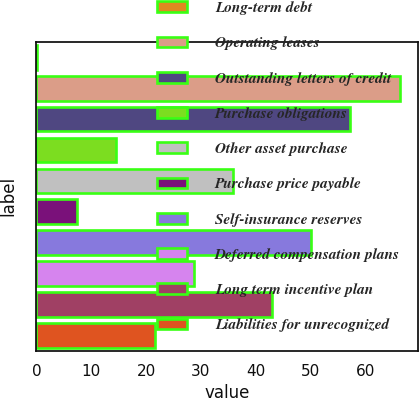Convert chart. <chart><loc_0><loc_0><loc_500><loc_500><bar_chart><fcel>Long-term debt<fcel>Operating leases<fcel>Outstanding letters of credit<fcel>Purchase obligations<fcel>Other asset purchase<fcel>Purchase price payable<fcel>Self-insurance reserves<fcel>Deferred compensation plans<fcel>Long term incentive plan<fcel>Liabilities for unrecognized<nl><fcel>0.2<fcel>66.3<fcel>57.24<fcel>14.46<fcel>35.85<fcel>7.33<fcel>50.11<fcel>28.72<fcel>42.98<fcel>21.59<nl></chart> 